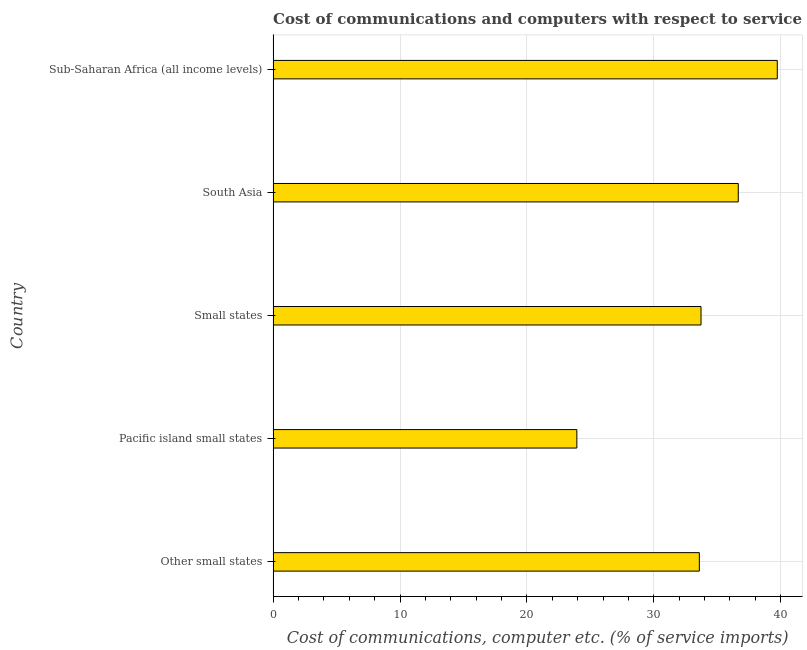Does the graph contain any zero values?
Your answer should be very brief. No. What is the title of the graph?
Provide a succinct answer. Cost of communications and computers with respect to service imports of countries in 2006. What is the label or title of the X-axis?
Offer a terse response. Cost of communications, computer etc. (% of service imports). What is the label or title of the Y-axis?
Offer a very short reply. Country. What is the cost of communications and computer in Sub-Saharan Africa (all income levels)?
Offer a terse response. 39.73. Across all countries, what is the maximum cost of communications and computer?
Your response must be concise. 39.73. Across all countries, what is the minimum cost of communications and computer?
Offer a terse response. 23.94. In which country was the cost of communications and computer maximum?
Keep it short and to the point. Sub-Saharan Africa (all income levels). In which country was the cost of communications and computer minimum?
Your answer should be compact. Pacific island small states. What is the sum of the cost of communications and computer?
Make the answer very short. 167.65. What is the difference between the cost of communications and computer in Small states and South Asia?
Offer a very short reply. -2.94. What is the average cost of communications and computer per country?
Make the answer very short. 33.53. What is the median cost of communications and computer?
Your answer should be compact. 33.72. In how many countries, is the cost of communications and computer greater than 12 %?
Give a very brief answer. 5. What is the ratio of the cost of communications and computer in Other small states to that in Pacific island small states?
Your answer should be very brief. 1.4. Is the difference between the cost of communications and computer in Other small states and Small states greater than the difference between any two countries?
Provide a short and direct response. No. What is the difference between the highest and the second highest cost of communications and computer?
Make the answer very short. 3.08. In how many countries, is the cost of communications and computer greater than the average cost of communications and computer taken over all countries?
Offer a terse response. 4. How many bars are there?
Give a very brief answer. 5. Are all the bars in the graph horizontal?
Your answer should be very brief. Yes. How many countries are there in the graph?
Provide a succinct answer. 5. Are the values on the major ticks of X-axis written in scientific E-notation?
Your answer should be very brief. No. What is the Cost of communications, computer etc. (% of service imports) of Other small states?
Your answer should be very brief. 33.59. What is the Cost of communications, computer etc. (% of service imports) in Pacific island small states?
Offer a very short reply. 23.94. What is the Cost of communications, computer etc. (% of service imports) of Small states?
Your answer should be very brief. 33.72. What is the Cost of communications, computer etc. (% of service imports) of South Asia?
Provide a succinct answer. 36.66. What is the Cost of communications, computer etc. (% of service imports) of Sub-Saharan Africa (all income levels)?
Provide a short and direct response. 39.73. What is the difference between the Cost of communications, computer etc. (% of service imports) in Other small states and Pacific island small states?
Provide a succinct answer. 9.65. What is the difference between the Cost of communications, computer etc. (% of service imports) in Other small states and Small states?
Your answer should be compact. -0.13. What is the difference between the Cost of communications, computer etc. (% of service imports) in Other small states and South Asia?
Ensure brevity in your answer.  -3.07. What is the difference between the Cost of communications, computer etc. (% of service imports) in Other small states and Sub-Saharan Africa (all income levels)?
Offer a very short reply. -6.14. What is the difference between the Cost of communications, computer etc. (% of service imports) in Pacific island small states and Small states?
Your response must be concise. -9.79. What is the difference between the Cost of communications, computer etc. (% of service imports) in Pacific island small states and South Asia?
Offer a terse response. -12.72. What is the difference between the Cost of communications, computer etc. (% of service imports) in Pacific island small states and Sub-Saharan Africa (all income levels)?
Your response must be concise. -15.8. What is the difference between the Cost of communications, computer etc. (% of service imports) in Small states and South Asia?
Make the answer very short. -2.94. What is the difference between the Cost of communications, computer etc. (% of service imports) in Small states and Sub-Saharan Africa (all income levels)?
Give a very brief answer. -6.01. What is the difference between the Cost of communications, computer etc. (% of service imports) in South Asia and Sub-Saharan Africa (all income levels)?
Give a very brief answer. -3.07. What is the ratio of the Cost of communications, computer etc. (% of service imports) in Other small states to that in Pacific island small states?
Offer a very short reply. 1.4. What is the ratio of the Cost of communications, computer etc. (% of service imports) in Other small states to that in South Asia?
Ensure brevity in your answer.  0.92. What is the ratio of the Cost of communications, computer etc. (% of service imports) in Other small states to that in Sub-Saharan Africa (all income levels)?
Give a very brief answer. 0.84. What is the ratio of the Cost of communications, computer etc. (% of service imports) in Pacific island small states to that in Small states?
Keep it short and to the point. 0.71. What is the ratio of the Cost of communications, computer etc. (% of service imports) in Pacific island small states to that in South Asia?
Provide a short and direct response. 0.65. What is the ratio of the Cost of communications, computer etc. (% of service imports) in Pacific island small states to that in Sub-Saharan Africa (all income levels)?
Offer a terse response. 0.6. What is the ratio of the Cost of communications, computer etc. (% of service imports) in Small states to that in Sub-Saharan Africa (all income levels)?
Make the answer very short. 0.85. What is the ratio of the Cost of communications, computer etc. (% of service imports) in South Asia to that in Sub-Saharan Africa (all income levels)?
Provide a succinct answer. 0.92. 